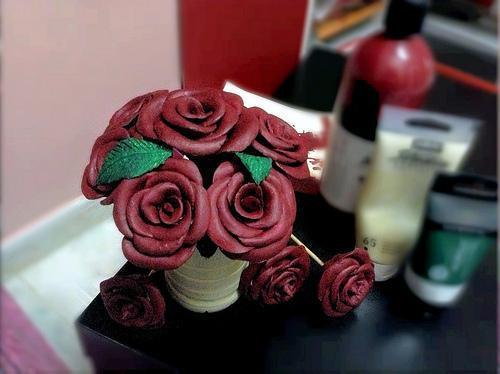How many roses are there?
Give a very brief answer. 9. 